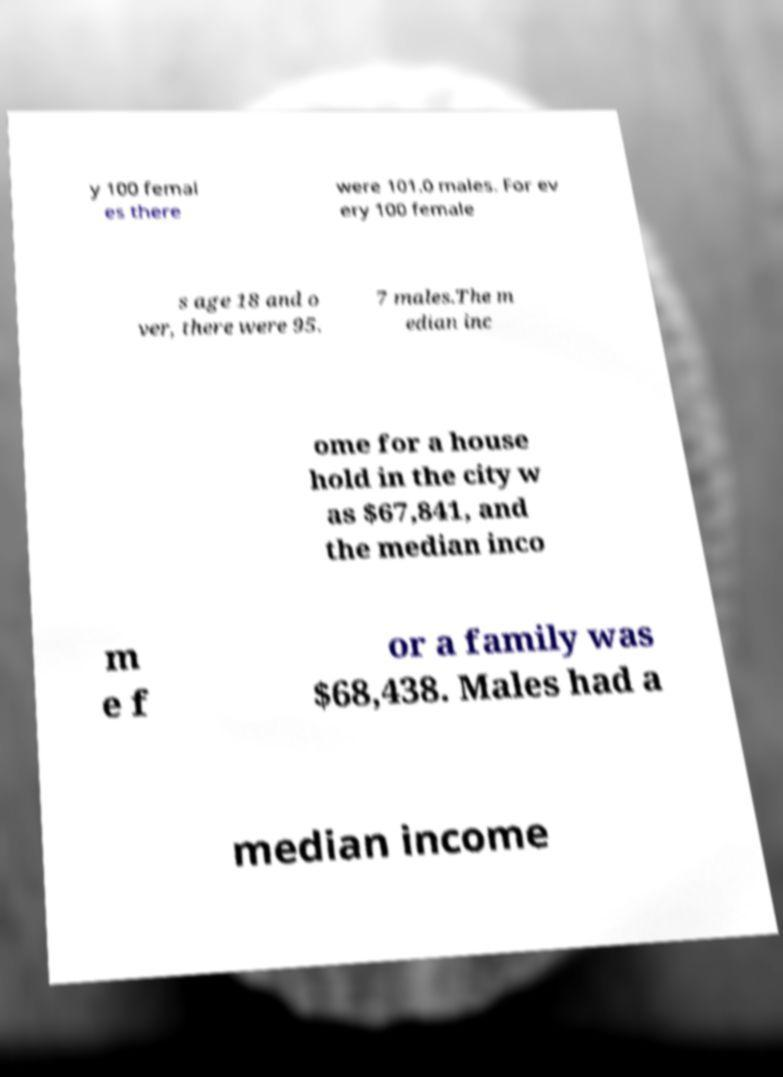Could you extract and type out the text from this image? y 100 femal es there were 101.0 males. For ev ery 100 female s age 18 and o ver, there were 95. 7 males.The m edian inc ome for a house hold in the city w as $67,841, and the median inco m e f or a family was $68,438. Males had a median income 